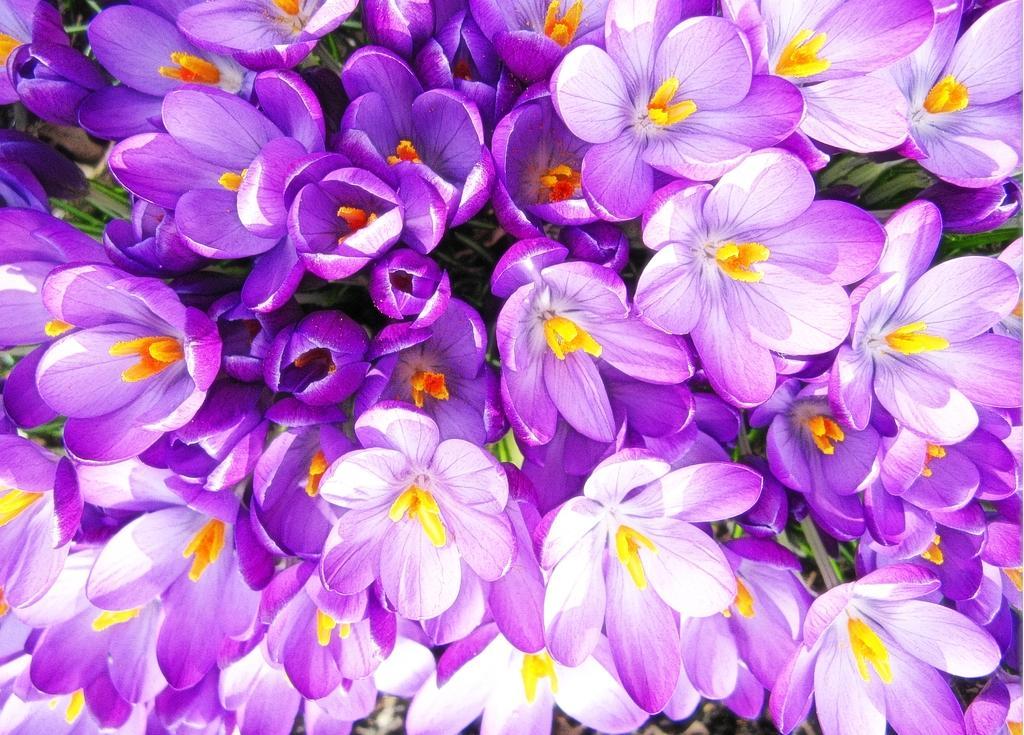Could you give a brief overview of what you see in this image? In the picture we can see a group of flowers which are violet in color and some yellow petals in the middle and in the middle of the flowers we can see some plant saplings. 